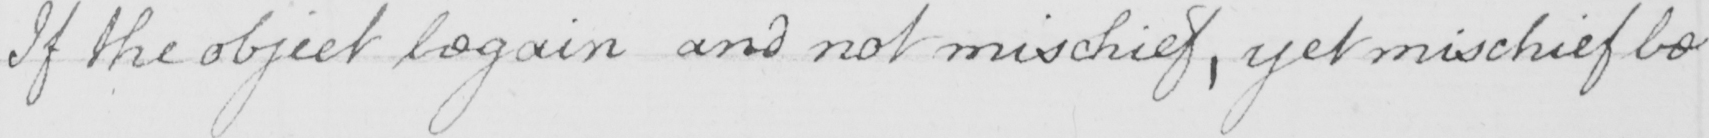Can you tell me what this handwritten text says? If the object be gain and not mischief , yet mischief be 